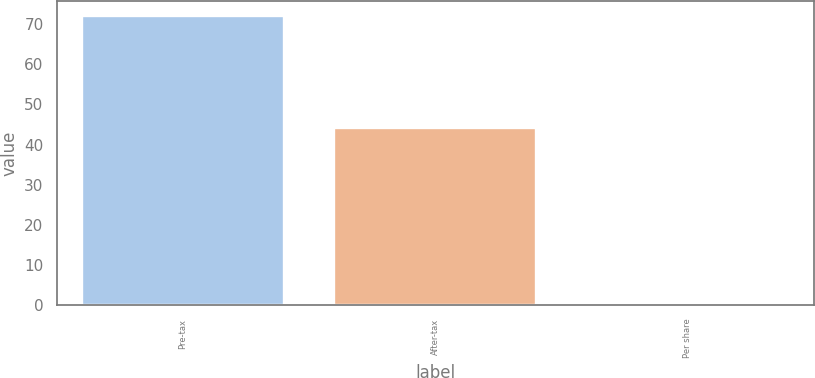<chart> <loc_0><loc_0><loc_500><loc_500><bar_chart><fcel>Pre-tax<fcel>After-tax<fcel>Per share<nl><fcel>72<fcel>44<fcel>0.03<nl></chart> 